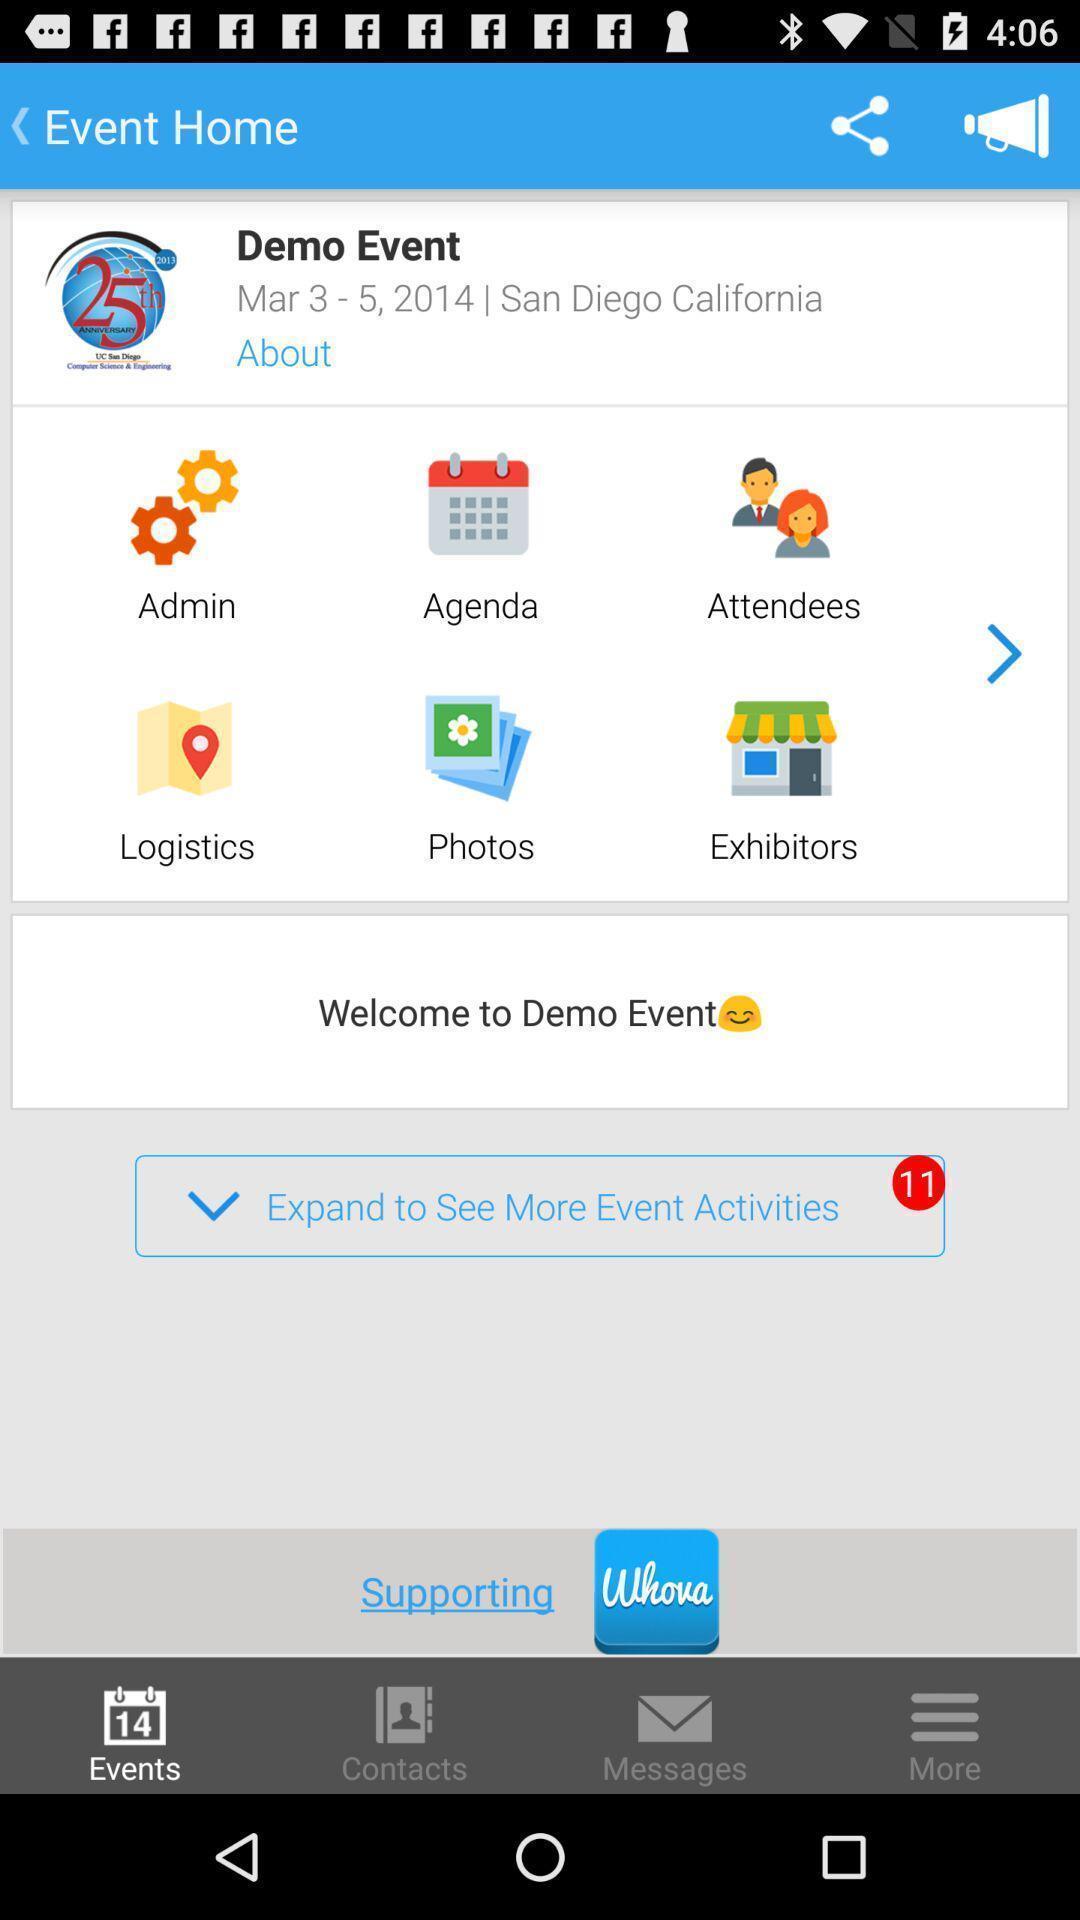Provide a detailed account of this screenshot. Page shows different options. 